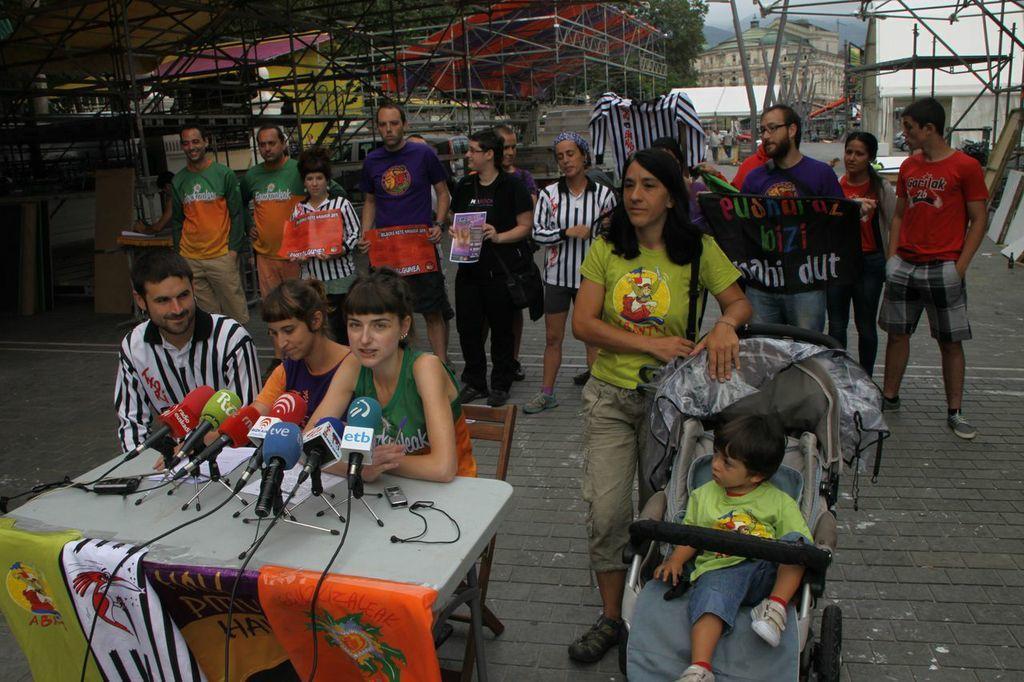Describe this image in one or two sentences. In this image we can see a group of persons and among them few persons are holding objects. In the foreground we can see a few mics on a table and there are a few banners attached to the table. Behind the table, we can see few persons on chairs. Behind the persons we can see metal rods, trees and buildings. 